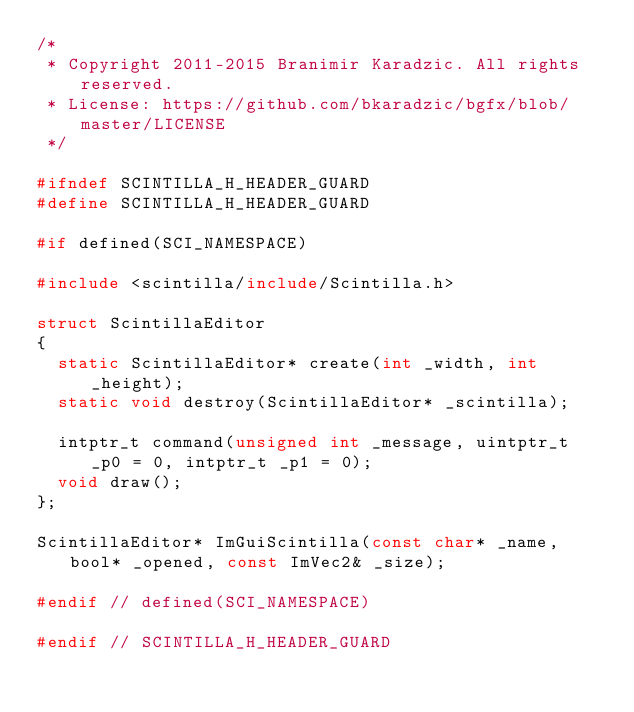Convert code to text. <code><loc_0><loc_0><loc_500><loc_500><_C_>/*
 * Copyright 2011-2015 Branimir Karadzic. All rights reserved.
 * License: https://github.com/bkaradzic/bgfx/blob/master/LICENSE
 */

#ifndef SCINTILLA_H_HEADER_GUARD
#define SCINTILLA_H_HEADER_GUARD

#if defined(SCI_NAMESPACE)

#include <scintilla/include/Scintilla.h>

struct ScintillaEditor
{
	static ScintillaEditor* create(int _width, int _height);
	static void destroy(ScintillaEditor* _scintilla);

	intptr_t command(unsigned int _message, uintptr_t _p0 = 0, intptr_t _p1 = 0);
	void draw();
};

ScintillaEditor* ImGuiScintilla(const char* _name, bool* _opened, const ImVec2& _size);

#endif // defined(SCI_NAMESPACE)

#endif // SCINTILLA_H_HEADER_GUARD
</code> 